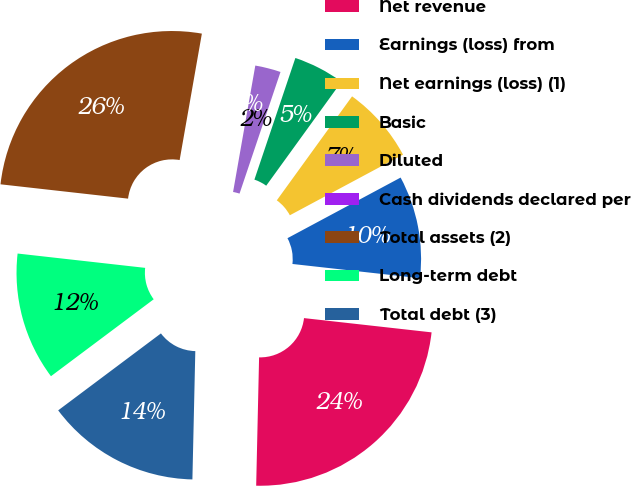<chart> <loc_0><loc_0><loc_500><loc_500><pie_chart><fcel>Net revenue<fcel>Earnings (loss) from<fcel>Net earnings (loss) (1)<fcel>Basic<fcel>Diluted<fcel>Cash dividends declared per<fcel>Total assets (2)<fcel>Long-term debt<fcel>Total debt (3)<nl><fcel>23.59%<fcel>9.6%<fcel>7.2%<fcel>4.8%<fcel>2.4%<fcel>0.0%<fcel>25.99%<fcel>12.01%<fcel>14.41%<nl></chart> 